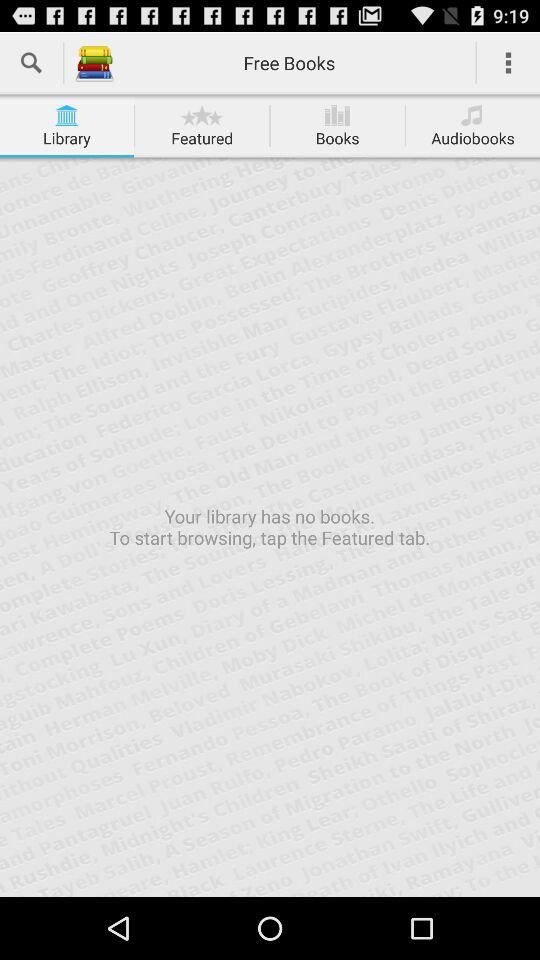What tab is selected? The selected tab is "Library". 